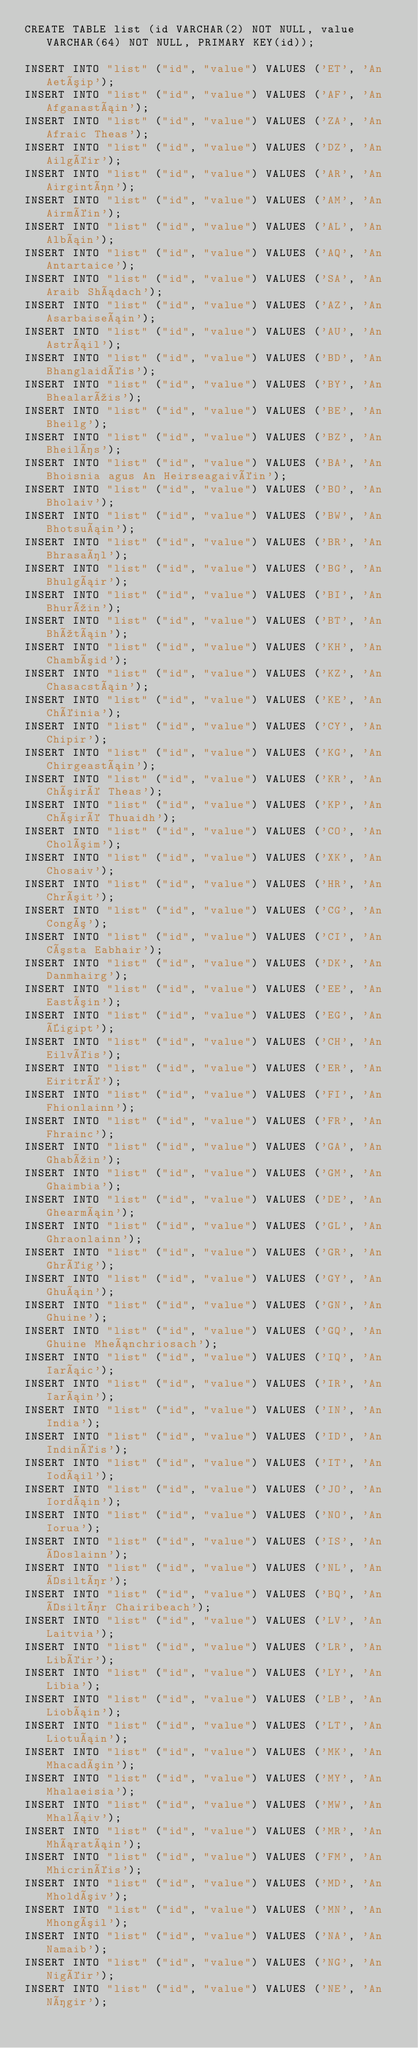<code> <loc_0><loc_0><loc_500><loc_500><_SQL_>CREATE TABLE list (id VARCHAR(2) NOT NULL, value VARCHAR(64) NOT NULL, PRIMARY KEY(id));

INSERT INTO "list" ("id", "value") VALUES ('ET', 'An Aetóip');
INSERT INTO "list" ("id", "value") VALUES ('AF', 'An Afganastáin');
INSERT INTO "list" ("id", "value") VALUES ('ZA', 'An Afraic Theas');
INSERT INTO "list" ("id", "value") VALUES ('DZ', 'An Ailgéir');
INSERT INTO "list" ("id", "value") VALUES ('AR', 'An Airgintín');
INSERT INTO "list" ("id", "value") VALUES ('AM', 'An Airméin');
INSERT INTO "list" ("id", "value") VALUES ('AL', 'An Albáin');
INSERT INTO "list" ("id", "value") VALUES ('AQ', 'An Antartaice');
INSERT INTO "list" ("id", "value") VALUES ('SA', 'An Araib Shádach');
INSERT INTO "list" ("id", "value") VALUES ('AZ', 'An Asarbaiseáin');
INSERT INTO "list" ("id", "value") VALUES ('AU', 'An Astráil');
INSERT INTO "list" ("id", "value") VALUES ('BD', 'An Bhanglaidéis');
INSERT INTO "list" ("id", "value") VALUES ('BY', 'An Bhealarúis');
INSERT INTO "list" ("id", "value") VALUES ('BE', 'An Bheilg');
INSERT INTO "list" ("id", "value") VALUES ('BZ', 'An Bheilís');
INSERT INTO "list" ("id", "value") VALUES ('BA', 'An Bhoisnia agus An Heirseagaivéin');
INSERT INTO "list" ("id", "value") VALUES ('BO', 'An Bholaiv');
INSERT INTO "list" ("id", "value") VALUES ('BW', 'An Bhotsuáin');
INSERT INTO "list" ("id", "value") VALUES ('BR', 'An Bhrasaíl');
INSERT INTO "list" ("id", "value") VALUES ('BG', 'An Bhulgáir');
INSERT INTO "list" ("id", "value") VALUES ('BI', 'An Bhurúin');
INSERT INTO "list" ("id", "value") VALUES ('BT', 'An Bhútáin');
INSERT INTO "list" ("id", "value") VALUES ('KH', 'An Chambóid');
INSERT INTO "list" ("id", "value") VALUES ('KZ', 'An Chasacstáin');
INSERT INTO "list" ("id", "value") VALUES ('KE', 'An Chéinia');
INSERT INTO "list" ("id", "value") VALUES ('CY', 'An Chipir');
INSERT INTO "list" ("id", "value") VALUES ('KG', 'An Chirgeastáin');
INSERT INTO "list" ("id", "value") VALUES ('KR', 'An Chóiré Theas');
INSERT INTO "list" ("id", "value") VALUES ('KP', 'An Chóiré Thuaidh');
INSERT INTO "list" ("id", "value") VALUES ('CO', 'An Cholóim');
INSERT INTO "list" ("id", "value") VALUES ('XK', 'An Chosaiv');
INSERT INTO "list" ("id", "value") VALUES ('HR', 'An Chróit');
INSERT INTO "list" ("id", "value") VALUES ('CG', 'An Congó');
INSERT INTO "list" ("id", "value") VALUES ('CI', 'An Cósta Eabhair');
INSERT INTO "list" ("id", "value") VALUES ('DK', 'An Danmhairg');
INSERT INTO "list" ("id", "value") VALUES ('EE', 'An Eastóin');
INSERT INTO "list" ("id", "value") VALUES ('EG', 'An Éigipt');
INSERT INTO "list" ("id", "value") VALUES ('CH', 'An Eilvéis');
INSERT INTO "list" ("id", "value") VALUES ('ER', 'An Eiritré');
INSERT INTO "list" ("id", "value") VALUES ('FI', 'An Fhionlainn');
INSERT INTO "list" ("id", "value") VALUES ('FR', 'An Fhrainc');
INSERT INTO "list" ("id", "value") VALUES ('GA', 'An Ghabúin');
INSERT INTO "list" ("id", "value") VALUES ('GM', 'An Ghaimbia');
INSERT INTO "list" ("id", "value") VALUES ('DE', 'An Ghearmáin');
INSERT INTO "list" ("id", "value") VALUES ('GL', 'An Ghraonlainn');
INSERT INTO "list" ("id", "value") VALUES ('GR', 'An Ghréig');
INSERT INTO "list" ("id", "value") VALUES ('GY', 'An Ghuáin');
INSERT INTO "list" ("id", "value") VALUES ('GN', 'An Ghuine');
INSERT INTO "list" ("id", "value") VALUES ('GQ', 'An Ghuine Mheánchriosach');
INSERT INTO "list" ("id", "value") VALUES ('IQ', 'An Iaráic');
INSERT INTO "list" ("id", "value") VALUES ('IR', 'An Iaráin');
INSERT INTO "list" ("id", "value") VALUES ('IN', 'An India');
INSERT INTO "list" ("id", "value") VALUES ('ID', 'An Indinéis');
INSERT INTO "list" ("id", "value") VALUES ('IT', 'An Iodáil');
INSERT INTO "list" ("id", "value") VALUES ('JO', 'An Iordáin');
INSERT INTO "list" ("id", "value") VALUES ('NO', 'An Iorua');
INSERT INTO "list" ("id", "value") VALUES ('IS', 'An Íoslainn');
INSERT INTO "list" ("id", "value") VALUES ('NL', 'An Ísiltír');
INSERT INTO "list" ("id", "value") VALUES ('BQ', 'An Ísiltír Chairibeach');
INSERT INTO "list" ("id", "value") VALUES ('LV', 'An Laitvia');
INSERT INTO "list" ("id", "value") VALUES ('LR', 'An Libéir');
INSERT INTO "list" ("id", "value") VALUES ('LY', 'An Libia');
INSERT INTO "list" ("id", "value") VALUES ('LB', 'An Liobáin');
INSERT INTO "list" ("id", "value") VALUES ('LT', 'An Liotuáin');
INSERT INTO "list" ("id", "value") VALUES ('MK', 'An Mhacadóin');
INSERT INTO "list" ("id", "value") VALUES ('MY', 'An Mhalaeisia');
INSERT INTO "list" ("id", "value") VALUES ('MW', 'An Mhaláiv');
INSERT INTO "list" ("id", "value") VALUES ('MR', 'An Mháratáin');
INSERT INTO "list" ("id", "value") VALUES ('FM', 'An Mhicrinéis');
INSERT INTO "list" ("id", "value") VALUES ('MD', 'An Mholdóiv');
INSERT INTO "list" ("id", "value") VALUES ('MN', 'An Mhongóil');
INSERT INTO "list" ("id", "value") VALUES ('NA', 'An Namaib');
INSERT INTO "list" ("id", "value") VALUES ('NG', 'An Nigéir');
INSERT INTO "list" ("id", "value") VALUES ('NE', 'An Nígir');</code> 